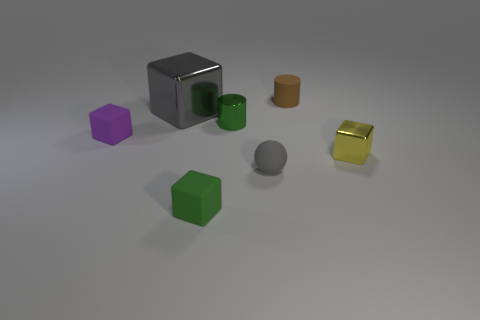Is the number of large green matte objects greater than the number of tiny brown things?
Make the answer very short. No. Do the small purple block and the tiny green cube have the same material?
Give a very brief answer. Yes. Are there the same number of small green cylinders on the right side of the small purple rubber block and big gray matte blocks?
Your answer should be very brief. No. How many large gray cubes have the same material as the small gray sphere?
Your response must be concise. 0. Are there fewer gray rubber cylinders than brown matte things?
Offer a very short reply. Yes. There is a metallic block left of the brown rubber cylinder; does it have the same color as the small sphere?
Give a very brief answer. Yes. How many small purple blocks are in front of the big cube to the left of the tiny block on the right side of the small brown object?
Offer a very short reply. 1. There is a tiny purple rubber cube; what number of small green things are behind it?
Make the answer very short. 1. The tiny shiny thing that is the same shape as the tiny purple matte thing is what color?
Your answer should be very brief. Yellow. The block that is behind the tiny rubber ball and on the right side of the gray metallic thing is made of what material?
Provide a short and direct response. Metal. 